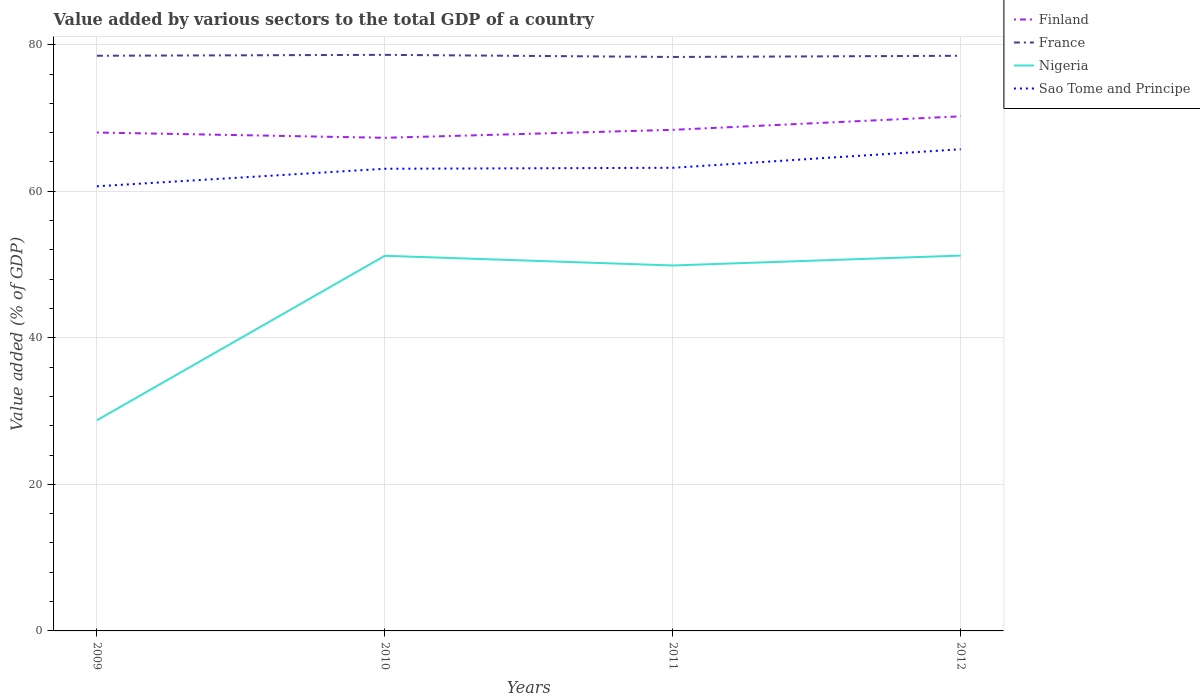Does the line corresponding to Finland intersect with the line corresponding to France?
Make the answer very short. No. Is the number of lines equal to the number of legend labels?
Keep it short and to the point. Yes. Across all years, what is the maximum value added by various sectors to the total GDP in Sao Tome and Principe?
Keep it short and to the point. 60.68. In which year was the value added by various sectors to the total GDP in Nigeria maximum?
Provide a short and direct response. 2009. What is the total value added by various sectors to the total GDP in Sao Tome and Principe in the graph?
Provide a succinct answer. -2.39. What is the difference between the highest and the second highest value added by various sectors to the total GDP in Finland?
Give a very brief answer. 2.93. What is the difference between the highest and the lowest value added by various sectors to the total GDP in France?
Keep it short and to the point. 3. What is the difference between two consecutive major ticks on the Y-axis?
Provide a short and direct response. 20. Are the values on the major ticks of Y-axis written in scientific E-notation?
Your answer should be very brief. No. Does the graph contain any zero values?
Make the answer very short. No. Does the graph contain grids?
Your answer should be compact. Yes. Where does the legend appear in the graph?
Ensure brevity in your answer.  Top right. How are the legend labels stacked?
Keep it short and to the point. Vertical. What is the title of the graph?
Your answer should be compact. Value added by various sectors to the total GDP of a country. Does "Liberia" appear as one of the legend labels in the graph?
Your response must be concise. No. What is the label or title of the Y-axis?
Your answer should be very brief. Value added (% of GDP). What is the Value added (% of GDP) in Finland in 2009?
Offer a terse response. 68.02. What is the Value added (% of GDP) in France in 2009?
Ensure brevity in your answer.  78.49. What is the Value added (% of GDP) in Nigeria in 2009?
Ensure brevity in your answer.  28.74. What is the Value added (% of GDP) in Sao Tome and Principe in 2009?
Provide a short and direct response. 60.68. What is the Value added (% of GDP) in Finland in 2010?
Your answer should be very brief. 67.3. What is the Value added (% of GDP) of France in 2010?
Offer a very short reply. 78.62. What is the Value added (% of GDP) in Nigeria in 2010?
Provide a succinct answer. 51.2. What is the Value added (% of GDP) in Sao Tome and Principe in 2010?
Ensure brevity in your answer.  63.07. What is the Value added (% of GDP) of Finland in 2011?
Your response must be concise. 68.38. What is the Value added (% of GDP) in France in 2011?
Ensure brevity in your answer.  78.33. What is the Value added (% of GDP) in Nigeria in 2011?
Offer a terse response. 49.87. What is the Value added (% of GDP) in Sao Tome and Principe in 2011?
Offer a very short reply. 63.2. What is the Value added (% of GDP) in Finland in 2012?
Offer a very short reply. 70.23. What is the Value added (% of GDP) in France in 2012?
Make the answer very short. 78.49. What is the Value added (% of GDP) in Nigeria in 2012?
Offer a terse response. 51.22. What is the Value added (% of GDP) in Sao Tome and Principe in 2012?
Keep it short and to the point. 65.73. Across all years, what is the maximum Value added (% of GDP) of Finland?
Give a very brief answer. 70.23. Across all years, what is the maximum Value added (% of GDP) in France?
Offer a very short reply. 78.62. Across all years, what is the maximum Value added (% of GDP) of Nigeria?
Provide a short and direct response. 51.22. Across all years, what is the maximum Value added (% of GDP) in Sao Tome and Principe?
Ensure brevity in your answer.  65.73. Across all years, what is the minimum Value added (% of GDP) of Finland?
Ensure brevity in your answer.  67.3. Across all years, what is the minimum Value added (% of GDP) in France?
Make the answer very short. 78.33. Across all years, what is the minimum Value added (% of GDP) of Nigeria?
Offer a terse response. 28.74. Across all years, what is the minimum Value added (% of GDP) of Sao Tome and Principe?
Keep it short and to the point. 60.68. What is the total Value added (% of GDP) of Finland in the graph?
Your answer should be very brief. 273.92. What is the total Value added (% of GDP) in France in the graph?
Your answer should be compact. 313.93. What is the total Value added (% of GDP) in Nigeria in the graph?
Give a very brief answer. 181.04. What is the total Value added (% of GDP) of Sao Tome and Principe in the graph?
Give a very brief answer. 252.69. What is the difference between the Value added (% of GDP) of Finland in 2009 and that in 2010?
Your answer should be compact. 0.72. What is the difference between the Value added (% of GDP) of France in 2009 and that in 2010?
Provide a short and direct response. -0.12. What is the difference between the Value added (% of GDP) in Nigeria in 2009 and that in 2010?
Give a very brief answer. -22.45. What is the difference between the Value added (% of GDP) in Sao Tome and Principe in 2009 and that in 2010?
Your response must be concise. -2.39. What is the difference between the Value added (% of GDP) of Finland in 2009 and that in 2011?
Give a very brief answer. -0.37. What is the difference between the Value added (% of GDP) in France in 2009 and that in 2011?
Give a very brief answer. 0.17. What is the difference between the Value added (% of GDP) of Nigeria in 2009 and that in 2011?
Make the answer very short. -21.13. What is the difference between the Value added (% of GDP) of Sao Tome and Principe in 2009 and that in 2011?
Your response must be concise. -2.52. What is the difference between the Value added (% of GDP) in Finland in 2009 and that in 2012?
Your answer should be very brief. -2.21. What is the difference between the Value added (% of GDP) in France in 2009 and that in 2012?
Your response must be concise. 0. What is the difference between the Value added (% of GDP) of Nigeria in 2009 and that in 2012?
Provide a succinct answer. -22.48. What is the difference between the Value added (% of GDP) of Sao Tome and Principe in 2009 and that in 2012?
Keep it short and to the point. -5.06. What is the difference between the Value added (% of GDP) of Finland in 2010 and that in 2011?
Keep it short and to the point. -1.09. What is the difference between the Value added (% of GDP) of France in 2010 and that in 2011?
Your answer should be compact. 0.29. What is the difference between the Value added (% of GDP) in Nigeria in 2010 and that in 2011?
Provide a short and direct response. 1.32. What is the difference between the Value added (% of GDP) in Sao Tome and Principe in 2010 and that in 2011?
Ensure brevity in your answer.  -0.13. What is the difference between the Value added (% of GDP) in Finland in 2010 and that in 2012?
Provide a succinct answer. -2.93. What is the difference between the Value added (% of GDP) in France in 2010 and that in 2012?
Ensure brevity in your answer.  0.13. What is the difference between the Value added (% of GDP) in Nigeria in 2010 and that in 2012?
Offer a very short reply. -0.03. What is the difference between the Value added (% of GDP) in Sao Tome and Principe in 2010 and that in 2012?
Ensure brevity in your answer.  -2.66. What is the difference between the Value added (% of GDP) in Finland in 2011 and that in 2012?
Provide a short and direct response. -1.84. What is the difference between the Value added (% of GDP) in France in 2011 and that in 2012?
Make the answer very short. -0.16. What is the difference between the Value added (% of GDP) in Nigeria in 2011 and that in 2012?
Give a very brief answer. -1.35. What is the difference between the Value added (% of GDP) of Sao Tome and Principe in 2011 and that in 2012?
Your response must be concise. -2.53. What is the difference between the Value added (% of GDP) of Finland in 2009 and the Value added (% of GDP) of France in 2010?
Provide a succinct answer. -10.6. What is the difference between the Value added (% of GDP) in Finland in 2009 and the Value added (% of GDP) in Nigeria in 2010?
Your answer should be compact. 16.82. What is the difference between the Value added (% of GDP) in Finland in 2009 and the Value added (% of GDP) in Sao Tome and Principe in 2010?
Provide a succinct answer. 4.95. What is the difference between the Value added (% of GDP) in France in 2009 and the Value added (% of GDP) in Nigeria in 2010?
Offer a terse response. 27.3. What is the difference between the Value added (% of GDP) of France in 2009 and the Value added (% of GDP) of Sao Tome and Principe in 2010?
Make the answer very short. 15.42. What is the difference between the Value added (% of GDP) of Nigeria in 2009 and the Value added (% of GDP) of Sao Tome and Principe in 2010?
Provide a short and direct response. -34.33. What is the difference between the Value added (% of GDP) of Finland in 2009 and the Value added (% of GDP) of France in 2011?
Provide a short and direct response. -10.31. What is the difference between the Value added (% of GDP) of Finland in 2009 and the Value added (% of GDP) of Nigeria in 2011?
Offer a very short reply. 18.14. What is the difference between the Value added (% of GDP) of Finland in 2009 and the Value added (% of GDP) of Sao Tome and Principe in 2011?
Provide a short and direct response. 4.82. What is the difference between the Value added (% of GDP) in France in 2009 and the Value added (% of GDP) in Nigeria in 2011?
Give a very brief answer. 28.62. What is the difference between the Value added (% of GDP) in France in 2009 and the Value added (% of GDP) in Sao Tome and Principe in 2011?
Offer a very short reply. 15.29. What is the difference between the Value added (% of GDP) in Nigeria in 2009 and the Value added (% of GDP) in Sao Tome and Principe in 2011?
Make the answer very short. -34.46. What is the difference between the Value added (% of GDP) in Finland in 2009 and the Value added (% of GDP) in France in 2012?
Ensure brevity in your answer.  -10.47. What is the difference between the Value added (% of GDP) in Finland in 2009 and the Value added (% of GDP) in Nigeria in 2012?
Give a very brief answer. 16.79. What is the difference between the Value added (% of GDP) in Finland in 2009 and the Value added (% of GDP) in Sao Tome and Principe in 2012?
Offer a terse response. 2.28. What is the difference between the Value added (% of GDP) in France in 2009 and the Value added (% of GDP) in Nigeria in 2012?
Provide a succinct answer. 27.27. What is the difference between the Value added (% of GDP) of France in 2009 and the Value added (% of GDP) of Sao Tome and Principe in 2012?
Make the answer very short. 12.76. What is the difference between the Value added (% of GDP) in Nigeria in 2009 and the Value added (% of GDP) in Sao Tome and Principe in 2012?
Make the answer very short. -36.99. What is the difference between the Value added (% of GDP) of Finland in 2010 and the Value added (% of GDP) of France in 2011?
Your answer should be compact. -11.03. What is the difference between the Value added (% of GDP) in Finland in 2010 and the Value added (% of GDP) in Nigeria in 2011?
Your answer should be very brief. 17.42. What is the difference between the Value added (% of GDP) in Finland in 2010 and the Value added (% of GDP) in Sao Tome and Principe in 2011?
Your answer should be very brief. 4.09. What is the difference between the Value added (% of GDP) of France in 2010 and the Value added (% of GDP) of Nigeria in 2011?
Give a very brief answer. 28.74. What is the difference between the Value added (% of GDP) in France in 2010 and the Value added (% of GDP) in Sao Tome and Principe in 2011?
Your answer should be compact. 15.41. What is the difference between the Value added (% of GDP) in Nigeria in 2010 and the Value added (% of GDP) in Sao Tome and Principe in 2011?
Your answer should be very brief. -12.01. What is the difference between the Value added (% of GDP) in Finland in 2010 and the Value added (% of GDP) in France in 2012?
Offer a very short reply. -11.19. What is the difference between the Value added (% of GDP) of Finland in 2010 and the Value added (% of GDP) of Nigeria in 2012?
Provide a succinct answer. 16.07. What is the difference between the Value added (% of GDP) of Finland in 2010 and the Value added (% of GDP) of Sao Tome and Principe in 2012?
Offer a terse response. 1.56. What is the difference between the Value added (% of GDP) in France in 2010 and the Value added (% of GDP) in Nigeria in 2012?
Your answer should be compact. 27.39. What is the difference between the Value added (% of GDP) in France in 2010 and the Value added (% of GDP) in Sao Tome and Principe in 2012?
Your answer should be compact. 12.88. What is the difference between the Value added (% of GDP) in Nigeria in 2010 and the Value added (% of GDP) in Sao Tome and Principe in 2012?
Keep it short and to the point. -14.54. What is the difference between the Value added (% of GDP) of Finland in 2011 and the Value added (% of GDP) of France in 2012?
Ensure brevity in your answer.  -10.11. What is the difference between the Value added (% of GDP) of Finland in 2011 and the Value added (% of GDP) of Nigeria in 2012?
Provide a succinct answer. 17.16. What is the difference between the Value added (% of GDP) of Finland in 2011 and the Value added (% of GDP) of Sao Tome and Principe in 2012?
Provide a short and direct response. 2.65. What is the difference between the Value added (% of GDP) of France in 2011 and the Value added (% of GDP) of Nigeria in 2012?
Make the answer very short. 27.1. What is the difference between the Value added (% of GDP) in France in 2011 and the Value added (% of GDP) in Sao Tome and Principe in 2012?
Give a very brief answer. 12.59. What is the difference between the Value added (% of GDP) in Nigeria in 2011 and the Value added (% of GDP) in Sao Tome and Principe in 2012?
Offer a terse response. -15.86. What is the average Value added (% of GDP) of Finland per year?
Your answer should be compact. 68.48. What is the average Value added (% of GDP) in France per year?
Your answer should be compact. 78.48. What is the average Value added (% of GDP) of Nigeria per year?
Offer a terse response. 45.26. What is the average Value added (% of GDP) in Sao Tome and Principe per year?
Keep it short and to the point. 63.17. In the year 2009, what is the difference between the Value added (% of GDP) of Finland and Value added (% of GDP) of France?
Your answer should be very brief. -10.48. In the year 2009, what is the difference between the Value added (% of GDP) of Finland and Value added (% of GDP) of Nigeria?
Give a very brief answer. 39.27. In the year 2009, what is the difference between the Value added (% of GDP) in Finland and Value added (% of GDP) in Sao Tome and Principe?
Give a very brief answer. 7.34. In the year 2009, what is the difference between the Value added (% of GDP) of France and Value added (% of GDP) of Nigeria?
Your answer should be very brief. 49.75. In the year 2009, what is the difference between the Value added (% of GDP) in France and Value added (% of GDP) in Sao Tome and Principe?
Make the answer very short. 17.81. In the year 2009, what is the difference between the Value added (% of GDP) in Nigeria and Value added (% of GDP) in Sao Tome and Principe?
Your answer should be very brief. -31.93. In the year 2010, what is the difference between the Value added (% of GDP) of Finland and Value added (% of GDP) of France?
Keep it short and to the point. -11.32. In the year 2010, what is the difference between the Value added (% of GDP) of Finland and Value added (% of GDP) of Nigeria?
Offer a very short reply. 16.1. In the year 2010, what is the difference between the Value added (% of GDP) of Finland and Value added (% of GDP) of Sao Tome and Principe?
Ensure brevity in your answer.  4.22. In the year 2010, what is the difference between the Value added (% of GDP) in France and Value added (% of GDP) in Nigeria?
Ensure brevity in your answer.  27.42. In the year 2010, what is the difference between the Value added (% of GDP) of France and Value added (% of GDP) of Sao Tome and Principe?
Provide a succinct answer. 15.54. In the year 2010, what is the difference between the Value added (% of GDP) in Nigeria and Value added (% of GDP) in Sao Tome and Principe?
Give a very brief answer. -11.88. In the year 2011, what is the difference between the Value added (% of GDP) of Finland and Value added (% of GDP) of France?
Offer a terse response. -9.95. In the year 2011, what is the difference between the Value added (% of GDP) in Finland and Value added (% of GDP) in Nigeria?
Offer a very short reply. 18.51. In the year 2011, what is the difference between the Value added (% of GDP) of Finland and Value added (% of GDP) of Sao Tome and Principe?
Give a very brief answer. 5.18. In the year 2011, what is the difference between the Value added (% of GDP) of France and Value added (% of GDP) of Nigeria?
Keep it short and to the point. 28.45. In the year 2011, what is the difference between the Value added (% of GDP) of France and Value added (% of GDP) of Sao Tome and Principe?
Offer a terse response. 15.13. In the year 2011, what is the difference between the Value added (% of GDP) in Nigeria and Value added (% of GDP) in Sao Tome and Principe?
Keep it short and to the point. -13.33. In the year 2012, what is the difference between the Value added (% of GDP) in Finland and Value added (% of GDP) in France?
Provide a short and direct response. -8.26. In the year 2012, what is the difference between the Value added (% of GDP) of Finland and Value added (% of GDP) of Nigeria?
Your answer should be compact. 19. In the year 2012, what is the difference between the Value added (% of GDP) of Finland and Value added (% of GDP) of Sao Tome and Principe?
Ensure brevity in your answer.  4.49. In the year 2012, what is the difference between the Value added (% of GDP) in France and Value added (% of GDP) in Nigeria?
Make the answer very short. 27.27. In the year 2012, what is the difference between the Value added (% of GDP) in France and Value added (% of GDP) in Sao Tome and Principe?
Offer a very short reply. 12.75. In the year 2012, what is the difference between the Value added (% of GDP) of Nigeria and Value added (% of GDP) of Sao Tome and Principe?
Your response must be concise. -14.51. What is the ratio of the Value added (% of GDP) of Finland in 2009 to that in 2010?
Make the answer very short. 1.01. What is the ratio of the Value added (% of GDP) of Nigeria in 2009 to that in 2010?
Provide a short and direct response. 0.56. What is the ratio of the Value added (% of GDP) in Sao Tome and Principe in 2009 to that in 2010?
Keep it short and to the point. 0.96. What is the ratio of the Value added (% of GDP) in France in 2009 to that in 2011?
Offer a very short reply. 1. What is the ratio of the Value added (% of GDP) of Nigeria in 2009 to that in 2011?
Give a very brief answer. 0.58. What is the ratio of the Value added (% of GDP) in Sao Tome and Principe in 2009 to that in 2011?
Your answer should be very brief. 0.96. What is the ratio of the Value added (% of GDP) in Finland in 2009 to that in 2012?
Your answer should be compact. 0.97. What is the ratio of the Value added (% of GDP) of France in 2009 to that in 2012?
Provide a succinct answer. 1. What is the ratio of the Value added (% of GDP) in Nigeria in 2009 to that in 2012?
Offer a very short reply. 0.56. What is the ratio of the Value added (% of GDP) of Finland in 2010 to that in 2011?
Ensure brevity in your answer.  0.98. What is the ratio of the Value added (% of GDP) of France in 2010 to that in 2011?
Your answer should be compact. 1. What is the ratio of the Value added (% of GDP) of Nigeria in 2010 to that in 2011?
Make the answer very short. 1.03. What is the ratio of the Value added (% of GDP) of France in 2010 to that in 2012?
Provide a short and direct response. 1. What is the ratio of the Value added (% of GDP) in Sao Tome and Principe in 2010 to that in 2012?
Keep it short and to the point. 0.96. What is the ratio of the Value added (% of GDP) of Finland in 2011 to that in 2012?
Ensure brevity in your answer.  0.97. What is the ratio of the Value added (% of GDP) in France in 2011 to that in 2012?
Your response must be concise. 1. What is the ratio of the Value added (% of GDP) of Nigeria in 2011 to that in 2012?
Offer a very short reply. 0.97. What is the ratio of the Value added (% of GDP) of Sao Tome and Principe in 2011 to that in 2012?
Offer a very short reply. 0.96. What is the difference between the highest and the second highest Value added (% of GDP) of Finland?
Your answer should be compact. 1.84. What is the difference between the highest and the second highest Value added (% of GDP) of France?
Your response must be concise. 0.12. What is the difference between the highest and the second highest Value added (% of GDP) in Nigeria?
Offer a terse response. 0.03. What is the difference between the highest and the second highest Value added (% of GDP) in Sao Tome and Principe?
Provide a short and direct response. 2.53. What is the difference between the highest and the lowest Value added (% of GDP) of Finland?
Make the answer very short. 2.93. What is the difference between the highest and the lowest Value added (% of GDP) in France?
Provide a succinct answer. 0.29. What is the difference between the highest and the lowest Value added (% of GDP) in Nigeria?
Provide a succinct answer. 22.48. What is the difference between the highest and the lowest Value added (% of GDP) of Sao Tome and Principe?
Give a very brief answer. 5.06. 